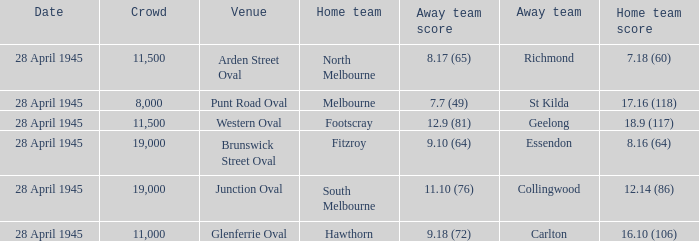Which home team has an Away team of essendon? 8.16 (64). 